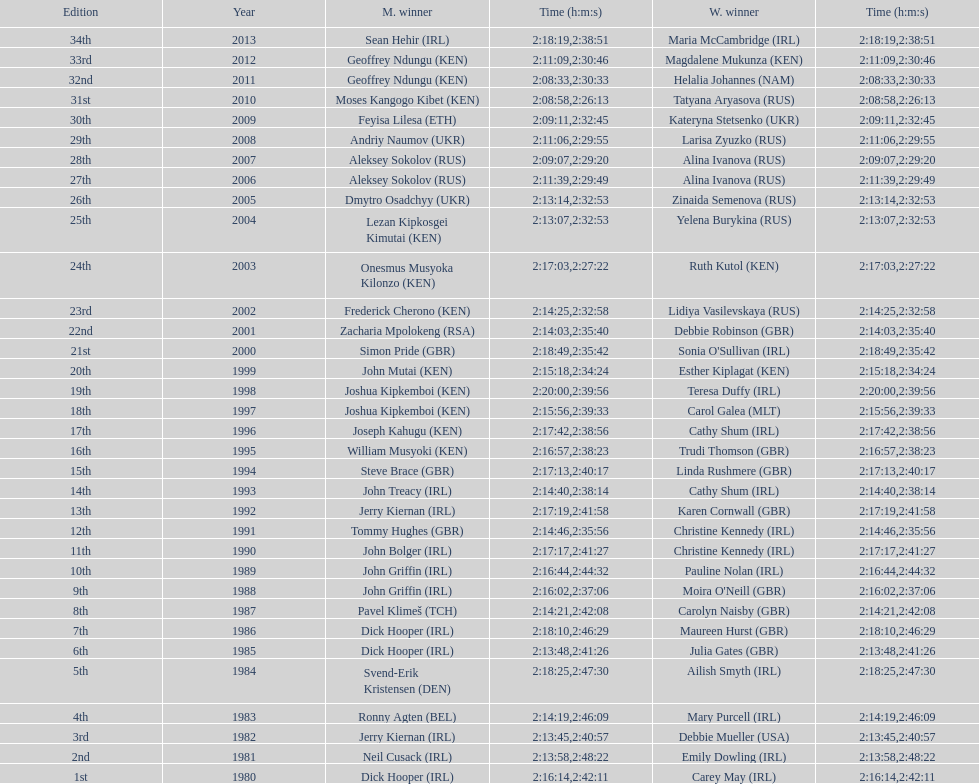How many women's winners are from kenya? 3. 